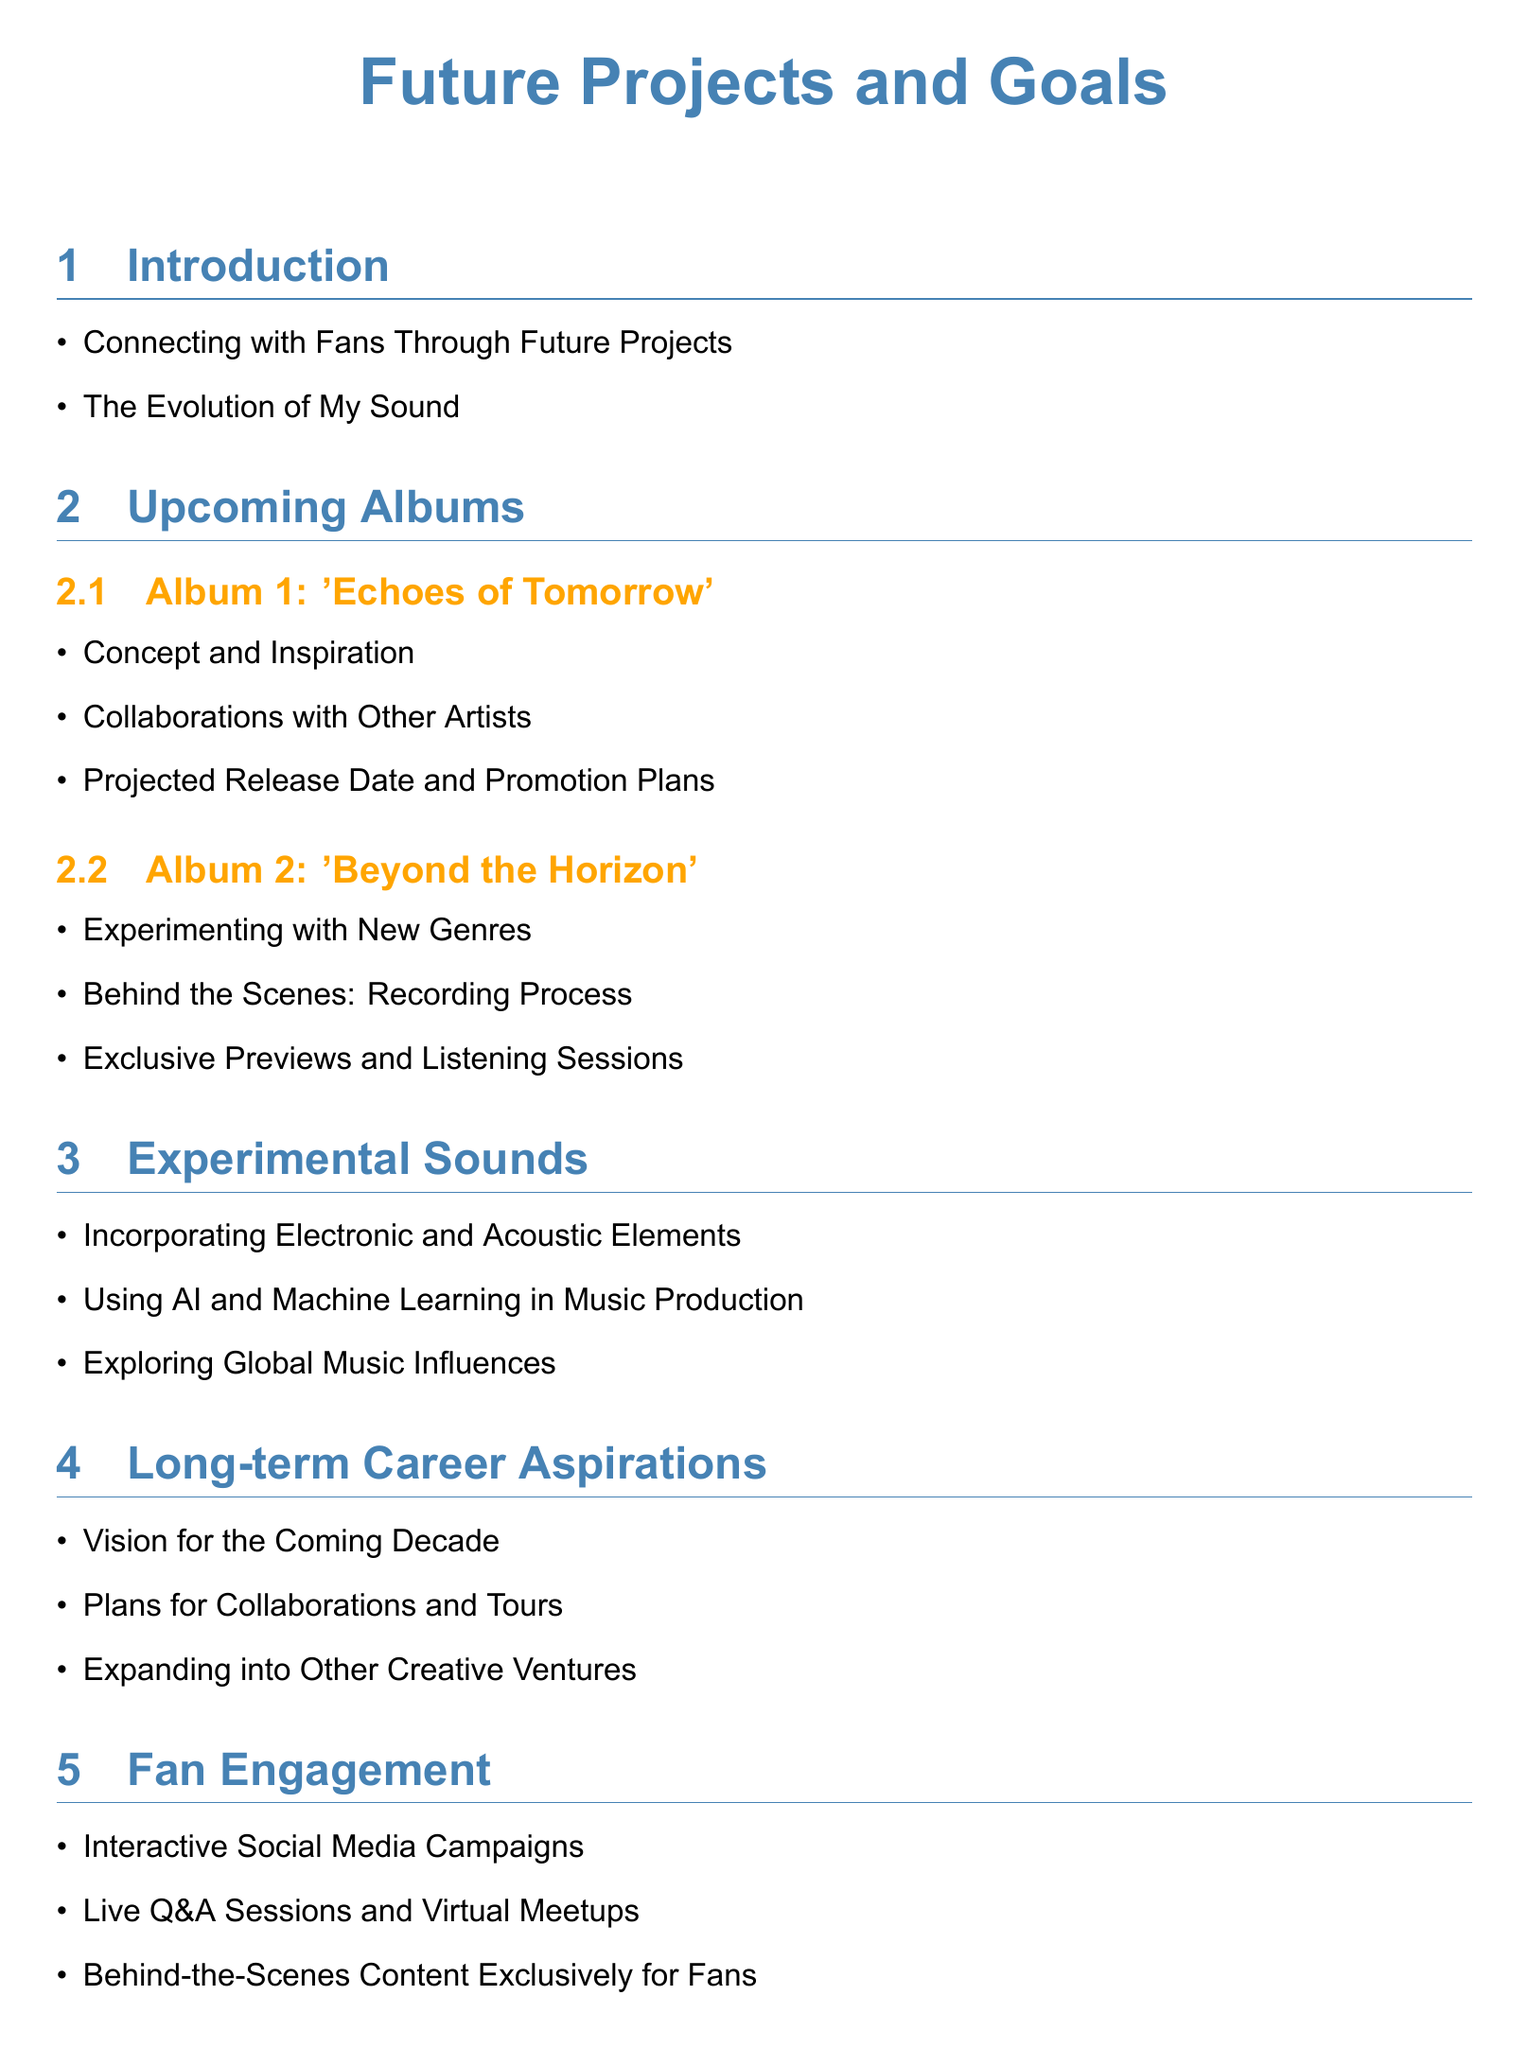What is the title of Album 1? The title of Album 1 is explicitly mentioned in the document.
Answer: 'Echoes of Tomorrow' What new elements are being incorporated into the music? The document lists various aspects of experimental sounds being explored in future projects.
Answer: Electronic and Acoustic Elements What is the vision mentioned for the coming decade? The document provides a section on long-term career aspirations, discussing future visions.
Answer: Vision for the Coming Decade When is Album 1 projected to be released? The document states that projected release dates are part of the information provided for upcoming albums.
Answer: Projected Release Date What type of process is highlighted for Album 2? The document outlines details about the recording process for Album 2.
Answer: Recording Process What innovative technology is mentioned for music production? The document includes references to specific technological advancements being utilized in music production.
Answer: AI and Machine Learning What type of campaigns are planned for fan engagement? The document specifies different forms of interaction with fans, including social media campaigns.
Answer: Interactive Social Media Campaigns What is expressed as a commitment in the conclusion? The document concludes with a statement about ongoing commitments related to music.
Answer: Musical Innovation 